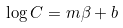Convert formula to latex. <formula><loc_0><loc_0><loc_500><loc_500>\log C = m \beta + b</formula> 